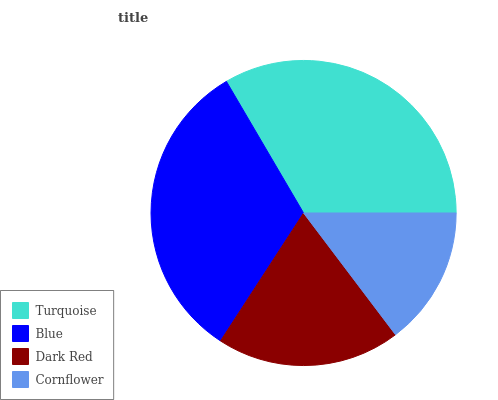Is Cornflower the minimum?
Answer yes or no. Yes. Is Turquoise the maximum?
Answer yes or no. Yes. Is Blue the minimum?
Answer yes or no. No. Is Blue the maximum?
Answer yes or no. No. Is Turquoise greater than Blue?
Answer yes or no. Yes. Is Blue less than Turquoise?
Answer yes or no. Yes. Is Blue greater than Turquoise?
Answer yes or no. No. Is Turquoise less than Blue?
Answer yes or no. No. Is Blue the high median?
Answer yes or no. Yes. Is Dark Red the low median?
Answer yes or no. Yes. Is Dark Red the high median?
Answer yes or no. No. Is Blue the low median?
Answer yes or no. No. 